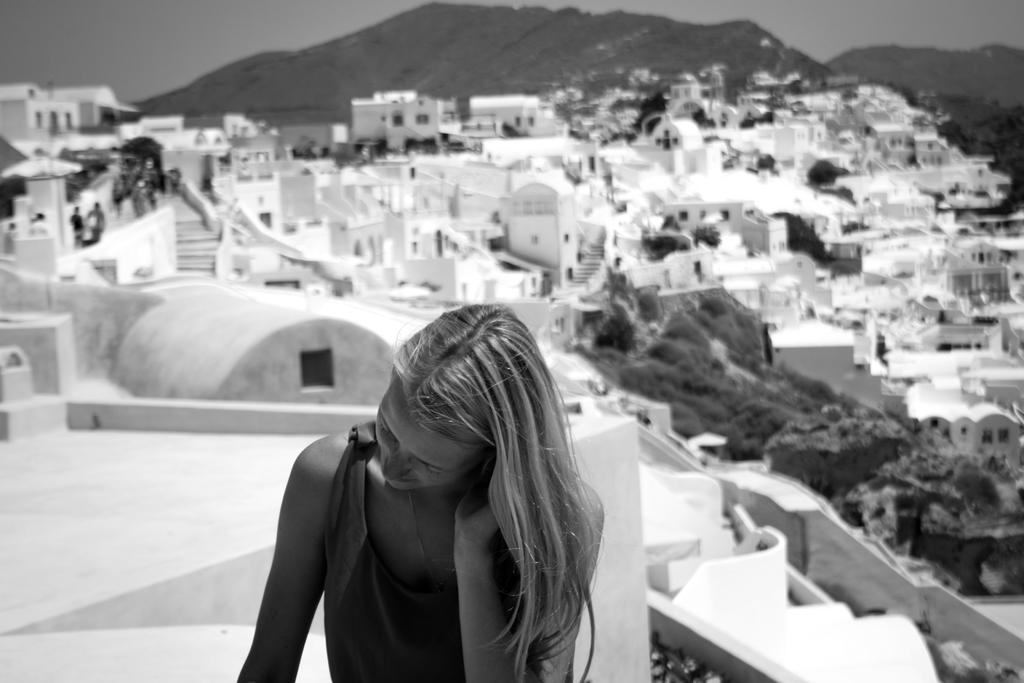What is the color scheme of the image? The image is black and white. Who is present in the image? There is a woman in the image. What type of natural environment is visible in the image? There are trees in the image. What type of man-made structures can be seen in the image? There are buildings in the image. Are there any other people in the image besides the woman? Yes, there are people in the image. What can be seen in the background of the image? There is a mountain and the sky visible in the background of the image. What type of calculator is being used by the woman in the image? There is no calculator present in the image. Is there a bridge visible in the image? No, there is no bridge visible in the image. 